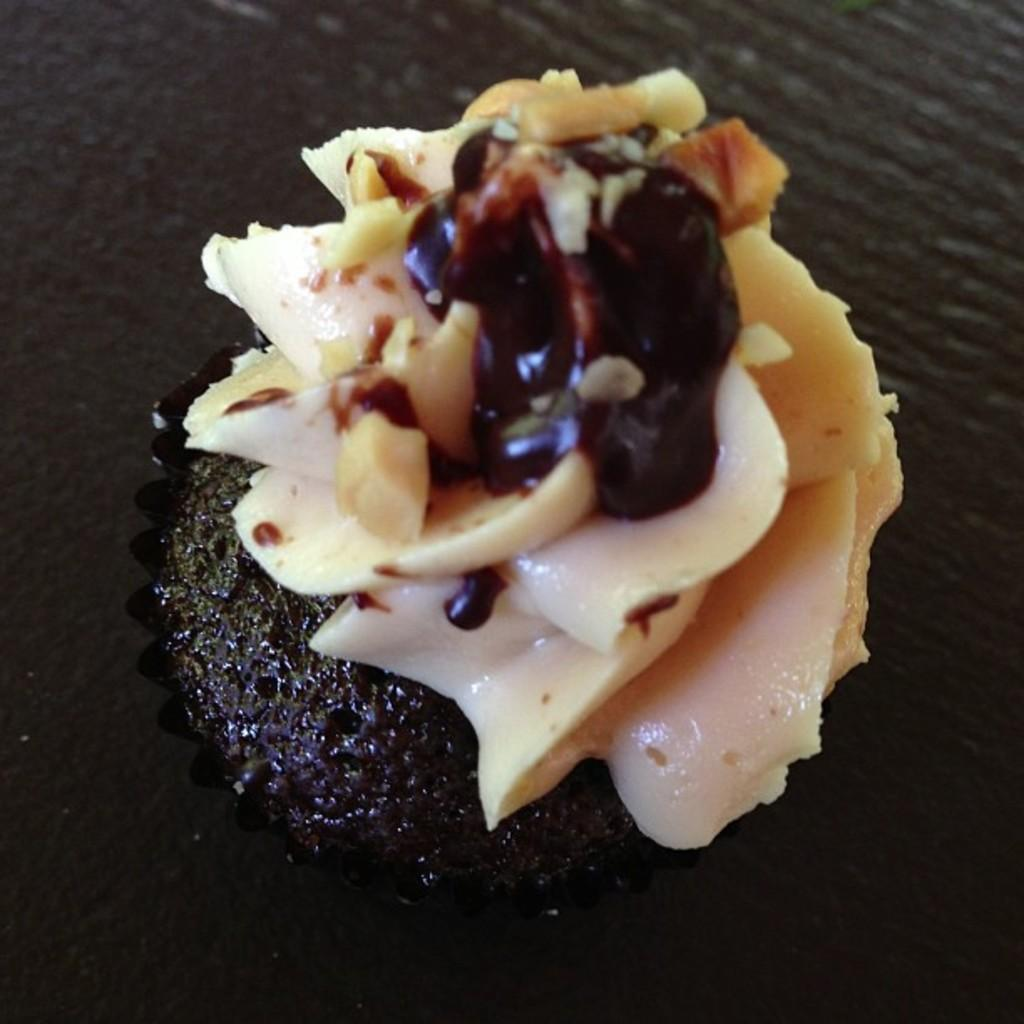What is the main subject of the image? There is a cake in the image. Where is the cake located? The cake is placed on a table. Can you describe the position of the cake in the image? The cake is in the center of the image. What type of sponge is used to clean the cake in the image? There is no sponge or cleaning activity depicted in the image; it simply shows a cake on a table. 